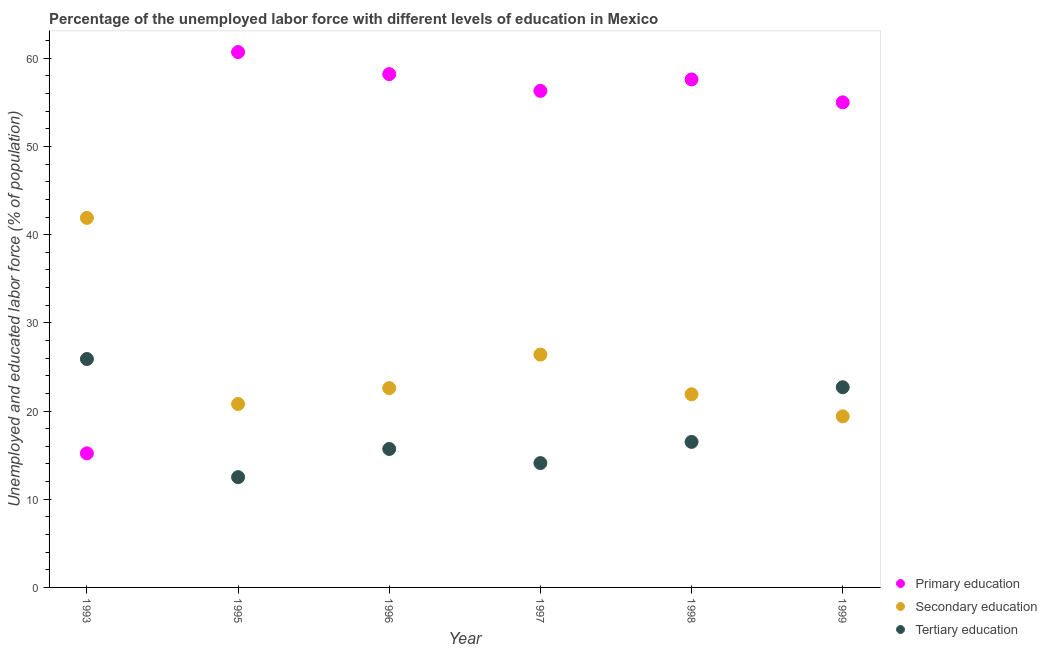How many different coloured dotlines are there?
Your answer should be compact. 3. Is the number of dotlines equal to the number of legend labels?
Offer a very short reply. Yes. What is the percentage of labor force who received primary education in 1996?
Provide a short and direct response. 58.2. Across all years, what is the maximum percentage of labor force who received tertiary education?
Offer a terse response. 25.9. Across all years, what is the minimum percentage of labor force who received primary education?
Offer a terse response. 15.2. In which year was the percentage of labor force who received tertiary education maximum?
Make the answer very short. 1993. In which year was the percentage of labor force who received primary education minimum?
Provide a short and direct response. 1993. What is the total percentage of labor force who received primary education in the graph?
Make the answer very short. 303. What is the difference between the percentage of labor force who received tertiary education in 1995 and that in 1999?
Your response must be concise. -10.2. What is the difference between the percentage of labor force who received primary education in 1999 and the percentage of labor force who received secondary education in 1995?
Your response must be concise. 34.2. What is the average percentage of labor force who received secondary education per year?
Keep it short and to the point. 25.5. In the year 1996, what is the difference between the percentage of labor force who received primary education and percentage of labor force who received secondary education?
Offer a terse response. 35.6. In how many years, is the percentage of labor force who received tertiary education greater than 52 %?
Your answer should be compact. 0. What is the ratio of the percentage of labor force who received tertiary education in 1997 to that in 1999?
Keep it short and to the point. 0.62. Is the percentage of labor force who received tertiary education in 1993 less than that in 1998?
Your answer should be compact. No. What is the difference between the highest and the second highest percentage of labor force who received tertiary education?
Your answer should be very brief. 3.2. What is the difference between the highest and the lowest percentage of labor force who received tertiary education?
Offer a very short reply. 13.4. In how many years, is the percentage of labor force who received secondary education greater than the average percentage of labor force who received secondary education taken over all years?
Provide a succinct answer. 2. Does the percentage of labor force who received secondary education monotonically increase over the years?
Your answer should be compact. No. How many dotlines are there?
Provide a short and direct response. 3. How many years are there in the graph?
Your answer should be very brief. 6. What is the difference between two consecutive major ticks on the Y-axis?
Keep it short and to the point. 10. Are the values on the major ticks of Y-axis written in scientific E-notation?
Your answer should be very brief. No. What is the title of the graph?
Keep it short and to the point. Percentage of the unemployed labor force with different levels of education in Mexico. What is the label or title of the Y-axis?
Offer a terse response. Unemployed and educated labor force (% of population). What is the Unemployed and educated labor force (% of population) of Primary education in 1993?
Your answer should be compact. 15.2. What is the Unemployed and educated labor force (% of population) of Secondary education in 1993?
Your answer should be compact. 41.9. What is the Unemployed and educated labor force (% of population) in Tertiary education in 1993?
Your answer should be very brief. 25.9. What is the Unemployed and educated labor force (% of population) in Primary education in 1995?
Ensure brevity in your answer.  60.7. What is the Unemployed and educated labor force (% of population) in Secondary education in 1995?
Your answer should be very brief. 20.8. What is the Unemployed and educated labor force (% of population) of Primary education in 1996?
Keep it short and to the point. 58.2. What is the Unemployed and educated labor force (% of population) in Secondary education in 1996?
Keep it short and to the point. 22.6. What is the Unemployed and educated labor force (% of population) of Tertiary education in 1996?
Give a very brief answer. 15.7. What is the Unemployed and educated labor force (% of population) in Primary education in 1997?
Ensure brevity in your answer.  56.3. What is the Unemployed and educated labor force (% of population) of Secondary education in 1997?
Your answer should be very brief. 26.4. What is the Unemployed and educated labor force (% of population) in Tertiary education in 1997?
Make the answer very short. 14.1. What is the Unemployed and educated labor force (% of population) in Primary education in 1998?
Provide a succinct answer. 57.6. What is the Unemployed and educated labor force (% of population) in Secondary education in 1998?
Your answer should be compact. 21.9. What is the Unemployed and educated labor force (% of population) in Secondary education in 1999?
Your response must be concise. 19.4. What is the Unemployed and educated labor force (% of population) of Tertiary education in 1999?
Your answer should be very brief. 22.7. Across all years, what is the maximum Unemployed and educated labor force (% of population) in Primary education?
Offer a very short reply. 60.7. Across all years, what is the maximum Unemployed and educated labor force (% of population) in Secondary education?
Provide a succinct answer. 41.9. Across all years, what is the maximum Unemployed and educated labor force (% of population) in Tertiary education?
Offer a terse response. 25.9. Across all years, what is the minimum Unemployed and educated labor force (% of population) of Primary education?
Offer a terse response. 15.2. Across all years, what is the minimum Unemployed and educated labor force (% of population) of Secondary education?
Make the answer very short. 19.4. Across all years, what is the minimum Unemployed and educated labor force (% of population) in Tertiary education?
Keep it short and to the point. 12.5. What is the total Unemployed and educated labor force (% of population) of Primary education in the graph?
Your response must be concise. 303. What is the total Unemployed and educated labor force (% of population) in Secondary education in the graph?
Your answer should be compact. 153. What is the total Unemployed and educated labor force (% of population) of Tertiary education in the graph?
Give a very brief answer. 107.4. What is the difference between the Unemployed and educated labor force (% of population) in Primary education in 1993 and that in 1995?
Make the answer very short. -45.5. What is the difference between the Unemployed and educated labor force (% of population) in Secondary education in 1993 and that in 1995?
Offer a terse response. 21.1. What is the difference between the Unemployed and educated labor force (% of population) in Primary education in 1993 and that in 1996?
Provide a succinct answer. -43. What is the difference between the Unemployed and educated labor force (% of population) of Secondary education in 1993 and that in 1996?
Give a very brief answer. 19.3. What is the difference between the Unemployed and educated labor force (% of population) of Tertiary education in 1993 and that in 1996?
Your answer should be very brief. 10.2. What is the difference between the Unemployed and educated labor force (% of population) of Primary education in 1993 and that in 1997?
Keep it short and to the point. -41.1. What is the difference between the Unemployed and educated labor force (% of population) in Secondary education in 1993 and that in 1997?
Ensure brevity in your answer.  15.5. What is the difference between the Unemployed and educated labor force (% of population) of Tertiary education in 1993 and that in 1997?
Your response must be concise. 11.8. What is the difference between the Unemployed and educated labor force (% of population) in Primary education in 1993 and that in 1998?
Your answer should be very brief. -42.4. What is the difference between the Unemployed and educated labor force (% of population) in Secondary education in 1993 and that in 1998?
Keep it short and to the point. 20. What is the difference between the Unemployed and educated labor force (% of population) in Primary education in 1993 and that in 1999?
Provide a succinct answer. -39.8. What is the difference between the Unemployed and educated labor force (% of population) of Tertiary education in 1993 and that in 1999?
Give a very brief answer. 3.2. What is the difference between the Unemployed and educated labor force (% of population) in Secondary education in 1995 and that in 1996?
Your answer should be compact. -1.8. What is the difference between the Unemployed and educated labor force (% of population) in Tertiary education in 1995 and that in 1996?
Give a very brief answer. -3.2. What is the difference between the Unemployed and educated labor force (% of population) in Secondary education in 1995 and that in 1997?
Ensure brevity in your answer.  -5.6. What is the difference between the Unemployed and educated labor force (% of population) of Tertiary education in 1995 and that in 1997?
Give a very brief answer. -1.6. What is the difference between the Unemployed and educated labor force (% of population) in Primary education in 1995 and that in 1998?
Provide a succinct answer. 3.1. What is the difference between the Unemployed and educated labor force (% of population) of Secondary education in 1995 and that in 1998?
Make the answer very short. -1.1. What is the difference between the Unemployed and educated labor force (% of population) in Primary education in 1995 and that in 1999?
Offer a very short reply. 5.7. What is the difference between the Unemployed and educated labor force (% of population) of Secondary education in 1995 and that in 1999?
Your answer should be very brief. 1.4. What is the difference between the Unemployed and educated labor force (% of population) in Tertiary education in 1995 and that in 1999?
Ensure brevity in your answer.  -10.2. What is the difference between the Unemployed and educated labor force (% of population) of Primary education in 1996 and that in 1997?
Ensure brevity in your answer.  1.9. What is the difference between the Unemployed and educated labor force (% of population) of Primary education in 1996 and that in 1998?
Keep it short and to the point. 0.6. What is the difference between the Unemployed and educated labor force (% of population) in Secondary education in 1996 and that in 1998?
Your answer should be very brief. 0.7. What is the difference between the Unemployed and educated labor force (% of population) of Tertiary education in 1996 and that in 1998?
Ensure brevity in your answer.  -0.8. What is the difference between the Unemployed and educated labor force (% of population) in Secondary education in 1996 and that in 1999?
Offer a very short reply. 3.2. What is the difference between the Unemployed and educated labor force (% of population) in Secondary education in 1997 and that in 1998?
Give a very brief answer. 4.5. What is the difference between the Unemployed and educated labor force (% of population) of Primary education in 1997 and that in 1999?
Keep it short and to the point. 1.3. What is the difference between the Unemployed and educated labor force (% of population) in Secondary education in 1997 and that in 1999?
Your response must be concise. 7. What is the difference between the Unemployed and educated labor force (% of population) in Tertiary education in 1997 and that in 1999?
Your answer should be very brief. -8.6. What is the difference between the Unemployed and educated labor force (% of population) in Secondary education in 1993 and the Unemployed and educated labor force (% of population) in Tertiary education in 1995?
Your response must be concise. 29.4. What is the difference between the Unemployed and educated labor force (% of population) in Primary education in 1993 and the Unemployed and educated labor force (% of population) in Tertiary education in 1996?
Ensure brevity in your answer.  -0.5. What is the difference between the Unemployed and educated labor force (% of population) in Secondary education in 1993 and the Unemployed and educated labor force (% of population) in Tertiary education in 1996?
Ensure brevity in your answer.  26.2. What is the difference between the Unemployed and educated labor force (% of population) of Primary education in 1993 and the Unemployed and educated labor force (% of population) of Secondary education in 1997?
Keep it short and to the point. -11.2. What is the difference between the Unemployed and educated labor force (% of population) of Primary education in 1993 and the Unemployed and educated labor force (% of population) of Tertiary education in 1997?
Offer a very short reply. 1.1. What is the difference between the Unemployed and educated labor force (% of population) of Secondary education in 1993 and the Unemployed and educated labor force (% of population) of Tertiary education in 1997?
Your answer should be very brief. 27.8. What is the difference between the Unemployed and educated labor force (% of population) in Primary education in 1993 and the Unemployed and educated labor force (% of population) in Secondary education in 1998?
Your answer should be very brief. -6.7. What is the difference between the Unemployed and educated labor force (% of population) in Primary education in 1993 and the Unemployed and educated labor force (% of population) in Tertiary education in 1998?
Offer a terse response. -1.3. What is the difference between the Unemployed and educated labor force (% of population) of Secondary education in 1993 and the Unemployed and educated labor force (% of population) of Tertiary education in 1998?
Make the answer very short. 25.4. What is the difference between the Unemployed and educated labor force (% of population) of Primary education in 1993 and the Unemployed and educated labor force (% of population) of Tertiary education in 1999?
Your answer should be very brief. -7.5. What is the difference between the Unemployed and educated labor force (% of population) of Secondary education in 1993 and the Unemployed and educated labor force (% of population) of Tertiary education in 1999?
Give a very brief answer. 19.2. What is the difference between the Unemployed and educated labor force (% of population) of Primary education in 1995 and the Unemployed and educated labor force (% of population) of Secondary education in 1996?
Keep it short and to the point. 38.1. What is the difference between the Unemployed and educated labor force (% of population) in Primary education in 1995 and the Unemployed and educated labor force (% of population) in Tertiary education in 1996?
Your answer should be compact. 45. What is the difference between the Unemployed and educated labor force (% of population) of Secondary education in 1995 and the Unemployed and educated labor force (% of population) of Tertiary education in 1996?
Provide a succinct answer. 5.1. What is the difference between the Unemployed and educated labor force (% of population) of Primary education in 1995 and the Unemployed and educated labor force (% of population) of Secondary education in 1997?
Your answer should be compact. 34.3. What is the difference between the Unemployed and educated labor force (% of population) in Primary education in 1995 and the Unemployed and educated labor force (% of population) in Tertiary education in 1997?
Give a very brief answer. 46.6. What is the difference between the Unemployed and educated labor force (% of population) of Secondary education in 1995 and the Unemployed and educated labor force (% of population) of Tertiary education in 1997?
Your response must be concise. 6.7. What is the difference between the Unemployed and educated labor force (% of population) of Primary education in 1995 and the Unemployed and educated labor force (% of population) of Secondary education in 1998?
Offer a terse response. 38.8. What is the difference between the Unemployed and educated labor force (% of population) in Primary education in 1995 and the Unemployed and educated labor force (% of population) in Tertiary education in 1998?
Give a very brief answer. 44.2. What is the difference between the Unemployed and educated labor force (% of population) in Primary education in 1995 and the Unemployed and educated labor force (% of population) in Secondary education in 1999?
Your response must be concise. 41.3. What is the difference between the Unemployed and educated labor force (% of population) in Primary education in 1995 and the Unemployed and educated labor force (% of population) in Tertiary education in 1999?
Keep it short and to the point. 38. What is the difference between the Unemployed and educated labor force (% of population) of Secondary education in 1995 and the Unemployed and educated labor force (% of population) of Tertiary education in 1999?
Make the answer very short. -1.9. What is the difference between the Unemployed and educated labor force (% of population) in Primary education in 1996 and the Unemployed and educated labor force (% of population) in Secondary education in 1997?
Offer a terse response. 31.8. What is the difference between the Unemployed and educated labor force (% of population) in Primary education in 1996 and the Unemployed and educated labor force (% of population) in Tertiary education in 1997?
Provide a succinct answer. 44.1. What is the difference between the Unemployed and educated labor force (% of population) of Primary education in 1996 and the Unemployed and educated labor force (% of population) of Secondary education in 1998?
Your answer should be very brief. 36.3. What is the difference between the Unemployed and educated labor force (% of population) in Primary education in 1996 and the Unemployed and educated labor force (% of population) in Tertiary education in 1998?
Ensure brevity in your answer.  41.7. What is the difference between the Unemployed and educated labor force (% of population) in Secondary education in 1996 and the Unemployed and educated labor force (% of population) in Tertiary education in 1998?
Your response must be concise. 6.1. What is the difference between the Unemployed and educated labor force (% of population) in Primary education in 1996 and the Unemployed and educated labor force (% of population) in Secondary education in 1999?
Give a very brief answer. 38.8. What is the difference between the Unemployed and educated labor force (% of population) of Primary education in 1996 and the Unemployed and educated labor force (% of population) of Tertiary education in 1999?
Give a very brief answer. 35.5. What is the difference between the Unemployed and educated labor force (% of population) in Primary education in 1997 and the Unemployed and educated labor force (% of population) in Secondary education in 1998?
Make the answer very short. 34.4. What is the difference between the Unemployed and educated labor force (% of population) of Primary education in 1997 and the Unemployed and educated labor force (% of population) of Tertiary education in 1998?
Ensure brevity in your answer.  39.8. What is the difference between the Unemployed and educated labor force (% of population) in Secondary education in 1997 and the Unemployed and educated labor force (% of population) in Tertiary education in 1998?
Provide a succinct answer. 9.9. What is the difference between the Unemployed and educated labor force (% of population) in Primary education in 1997 and the Unemployed and educated labor force (% of population) in Secondary education in 1999?
Your answer should be compact. 36.9. What is the difference between the Unemployed and educated labor force (% of population) in Primary education in 1997 and the Unemployed and educated labor force (% of population) in Tertiary education in 1999?
Your answer should be compact. 33.6. What is the difference between the Unemployed and educated labor force (% of population) in Secondary education in 1997 and the Unemployed and educated labor force (% of population) in Tertiary education in 1999?
Give a very brief answer. 3.7. What is the difference between the Unemployed and educated labor force (% of population) of Primary education in 1998 and the Unemployed and educated labor force (% of population) of Secondary education in 1999?
Keep it short and to the point. 38.2. What is the difference between the Unemployed and educated labor force (% of population) of Primary education in 1998 and the Unemployed and educated labor force (% of population) of Tertiary education in 1999?
Your response must be concise. 34.9. What is the difference between the Unemployed and educated labor force (% of population) of Secondary education in 1998 and the Unemployed and educated labor force (% of population) of Tertiary education in 1999?
Keep it short and to the point. -0.8. What is the average Unemployed and educated labor force (% of population) in Primary education per year?
Provide a short and direct response. 50.5. What is the average Unemployed and educated labor force (% of population) of Tertiary education per year?
Offer a very short reply. 17.9. In the year 1993, what is the difference between the Unemployed and educated labor force (% of population) of Primary education and Unemployed and educated labor force (% of population) of Secondary education?
Make the answer very short. -26.7. In the year 1993, what is the difference between the Unemployed and educated labor force (% of population) of Secondary education and Unemployed and educated labor force (% of population) of Tertiary education?
Your answer should be very brief. 16. In the year 1995, what is the difference between the Unemployed and educated labor force (% of population) in Primary education and Unemployed and educated labor force (% of population) in Secondary education?
Offer a very short reply. 39.9. In the year 1995, what is the difference between the Unemployed and educated labor force (% of population) in Primary education and Unemployed and educated labor force (% of population) in Tertiary education?
Give a very brief answer. 48.2. In the year 1996, what is the difference between the Unemployed and educated labor force (% of population) in Primary education and Unemployed and educated labor force (% of population) in Secondary education?
Offer a very short reply. 35.6. In the year 1996, what is the difference between the Unemployed and educated labor force (% of population) of Primary education and Unemployed and educated labor force (% of population) of Tertiary education?
Keep it short and to the point. 42.5. In the year 1996, what is the difference between the Unemployed and educated labor force (% of population) in Secondary education and Unemployed and educated labor force (% of population) in Tertiary education?
Your response must be concise. 6.9. In the year 1997, what is the difference between the Unemployed and educated labor force (% of population) of Primary education and Unemployed and educated labor force (% of population) of Secondary education?
Provide a succinct answer. 29.9. In the year 1997, what is the difference between the Unemployed and educated labor force (% of population) of Primary education and Unemployed and educated labor force (% of population) of Tertiary education?
Make the answer very short. 42.2. In the year 1997, what is the difference between the Unemployed and educated labor force (% of population) in Secondary education and Unemployed and educated labor force (% of population) in Tertiary education?
Offer a very short reply. 12.3. In the year 1998, what is the difference between the Unemployed and educated labor force (% of population) in Primary education and Unemployed and educated labor force (% of population) in Secondary education?
Your response must be concise. 35.7. In the year 1998, what is the difference between the Unemployed and educated labor force (% of population) in Primary education and Unemployed and educated labor force (% of population) in Tertiary education?
Your answer should be very brief. 41.1. In the year 1998, what is the difference between the Unemployed and educated labor force (% of population) in Secondary education and Unemployed and educated labor force (% of population) in Tertiary education?
Your answer should be very brief. 5.4. In the year 1999, what is the difference between the Unemployed and educated labor force (% of population) of Primary education and Unemployed and educated labor force (% of population) of Secondary education?
Offer a terse response. 35.6. In the year 1999, what is the difference between the Unemployed and educated labor force (% of population) in Primary education and Unemployed and educated labor force (% of population) in Tertiary education?
Ensure brevity in your answer.  32.3. What is the ratio of the Unemployed and educated labor force (% of population) in Primary education in 1993 to that in 1995?
Keep it short and to the point. 0.25. What is the ratio of the Unemployed and educated labor force (% of population) in Secondary education in 1993 to that in 1995?
Keep it short and to the point. 2.01. What is the ratio of the Unemployed and educated labor force (% of population) in Tertiary education in 1993 to that in 1995?
Ensure brevity in your answer.  2.07. What is the ratio of the Unemployed and educated labor force (% of population) in Primary education in 1993 to that in 1996?
Your answer should be very brief. 0.26. What is the ratio of the Unemployed and educated labor force (% of population) in Secondary education in 1993 to that in 1996?
Offer a terse response. 1.85. What is the ratio of the Unemployed and educated labor force (% of population) in Tertiary education in 1993 to that in 1996?
Offer a terse response. 1.65. What is the ratio of the Unemployed and educated labor force (% of population) of Primary education in 1993 to that in 1997?
Your response must be concise. 0.27. What is the ratio of the Unemployed and educated labor force (% of population) of Secondary education in 1993 to that in 1997?
Provide a succinct answer. 1.59. What is the ratio of the Unemployed and educated labor force (% of population) in Tertiary education in 1993 to that in 1997?
Ensure brevity in your answer.  1.84. What is the ratio of the Unemployed and educated labor force (% of population) in Primary education in 1993 to that in 1998?
Provide a succinct answer. 0.26. What is the ratio of the Unemployed and educated labor force (% of population) of Secondary education in 1993 to that in 1998?
Provide a short and direct response. 1.91. What is the ratio of the Unemployed and educated labor force (% of population) in Tertiary education in 1993 to that in 1998?
Offer a very short reply. 1.57. What is the ratio of the Unemployed and educated labor force (% of population) of Primary education in 1993 to that in 1999?
Your answer should be very brief. 0.28. What is the ratio of the Unemployed and educated labor force (% of population) of Secondary education in 1993 to that in 1999?
Offer a terse response. 2.16. What is the ratio of the Unemployed and educated labor force (% of population) in Tertiary education in 1993 to that in 1999?
Your answer should be compact. 1.14. What is the ratio of the Unemployed and educated labor force (% of population) in Primary education in 1995 to that in 1996?
Offer a very short reply. 1.04. What is the ratio of the Unemployed and educated labor force (% of population) in Secondary education in 1995 to that in 1996?
Your answer should be compact. 0.92. What is the ratio of the Unemployed and educated labor force (% of population) in Tertiary education in 1995 to that in 1996?
Offer a terse response. 0.8. What is the ratio of the Unemployed and educated labor force (% of population) of Primary education in 1995 to that in 1997?
Provide a short and direct response. 1.08. What is the ratio of the Unemployed and educated labor force (% of population) of Secondary education in 1995 to that in 1997?
Your answer should be compact. 0.79. What is the ratio of the Unemployed and educated labor force (% of population) in Tertiary education in 1995 to that in 1997?
Provide a succinct answer. 0.89. What is the ratio of the Unemployed and educated labor force (% of population) in Primary education in 1995 to that in 1998?
Your answer should be compact. 1.05. What is the ratio of the Unemployed and educated labor force (% of population) of Secondary education in 1995 to that in 1998?
Make the answer very short. 0.95. What is the ratio of the Unemployed and educated labor force (% of population) of Tertiary education in 1995 to that in 1998?
Offer a terse response. 0.76. What is the ratio of the Unemployed and educated labor force (% of population) of Primary education in 1995 to that in 1999?
Keep it short and to the point. 1.1. What is the ratio of the Unemployed and educated labor force (% of population) in Secondary education in 1995 to that in 1999?
Keep it short and to the point. 1.07. What is the ratio of the Unemployed and educated labor force (% of population) in Tertiary education in 1995 to that in 1999?
Provide a short and direct response. 0.55. What is the ratio of the Unemployed and educated labor force (% of population) of Primary education in 1996 to that in 1997?
Give a very brief answer. 1.03. What is the ratio of the Unemployed and educated labor force (% of population) in Secondary education in 1996 to that in 1997?
Your answer should be very brief. 0.86. What is the ratio of the Unemployed and educated labor force (% of population) of Tertiary education in 1996 to that in 1997?
Keep it short and to the point. 1.11. What is the ratio of the Unemployed and educated labor force (% of population) in Primary education in 1996 to that in 1998?
Make the answer very short. 1.01. What is the ratio of the Unemployed and educated labor force (% of population) in Secondary education in 1996 to that in 1998?
Keep it short and to the point. 1.03. What is the ratio of the Unemployed and educated labor force (% of population) in Tertiary education in 1996 to that in 1998?
Provide a succinct answer. 0.95. What is the ratio of the Unemployed and educated labor force (% of population) in Primary education in 1996 to that in 1999?
Provide a short and direct response. 1.06. What is the ratio of the Unemployed and educated labor force (% of population) of Secondary education in 1996 to that in 1999?
Make the answer very short. 1.16. What is the ratio of the Unemployed and educated labor force (% of population) of Tertiary education in 1996 to that in 1999?
Your answer should be compact. 0.69. What is the ratio of the Unemployed and educated labor force (% of population) of Primary education in 1997 to that in 1998?
Ensure brevity in your answer.  0.98. What is the ratio of the Unemployed and educated labor force (% of population) of Secondary education in 1997 to that in 1998?
Give a very brief answer. 1.21. What is the ratio of the Unemployed and educated labor force (% of population) of Tertiary education in 1997 to that in 1998?
Your answer should be very brief. 0.85. What is the ratio of the Unemployed and educated labor force (% of population) of Primary education in 1997 to that in 1999?
Give a very brief answer. 1.02. What is the ratio of the Unemployed and educated labor force (% of population) of Secondary education in 1997 to that in 1999?
Your response must be concise. 1.36. What is the ratio of the Unemployed and educated labor force (% of population) of Tertiary education in 1997 to that in 1999?
Offer a very short reply. 0.62. What is the ratio of the Unemployed and educated labor force (% of population) in Primary education in 1998 to that in 1999?
Offer a very short reply. 1.05. What is the ratio of the Unemployed and educated labor force (% of population) of Secondary education in 1998 to that in 1999?
Ensure brevity in your answer.  1.13. What is the ratio of the Unemployed and educated labor force (% of population) in Tertiary education in 1998 to that in 1999?
Provide a succinct answer. 0.73. What is the difference between the highest and the second highest Unemployed and educated labor force (% of population) in Primary education?
Your answer should be compact. 2.5. What is the difference between the highest and the second highest Unemployed and educated labor force (% of population) in Secondary education?
Provide a succinct answer. 15.5. What is the difference between the highest and the lowest Unemployed and educated labor force (% of population) in Primary education?
Provide a short and direct response. 45.5. What is the difference between the highest and the lowest Unemployed and educated labor force (% of population) of Secondary education?
Give a very brief answer. 22.5. What is the difference between the highest and the lowest Unemployed and educated labor force (% of population) in Tertiary education?
Ensure brevity in your answer.  13.4. 